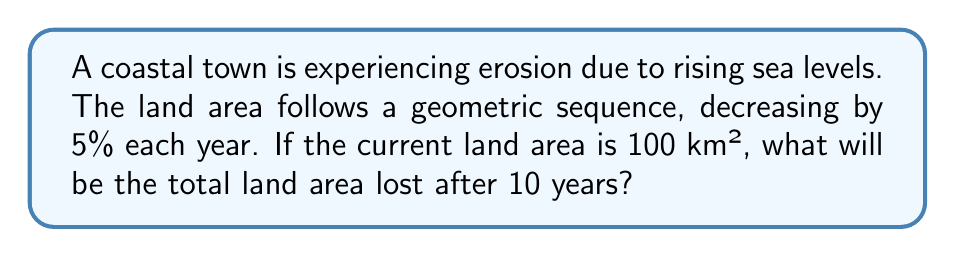Help me with this question. Let's approach this step-by-step:

1) The land area follows a geometric sequence with a common ratio of 0.95 (since it decreases by 5% each year, it retains 95% of its area).

2) The initial area $a_0 = 100$ km².

3) After 10 years, the area will be:
   $a_{10} = 100 \cdot (0.95)^{10}$ km²

4) To calculate this:
   $a_{10} = 100 \cdot (0.95)^{10} = 100 \cdot 0.5987 = 59.87$ km²

5) The total land area lost is the difference between the initial and final areas:
   $\text{Area lost} = a_0 - a_{10} = 100 - 59.87 = 40.13$ km²

6) To verify, we can use the sum of a geometric series formula:
   $$S_n = a_1\frac{1-r^n}{1-r}$$
   where $a_1 = 100 \cdot 0.05 = 5$ (the area lost in the first year) and $r = 0.95$

7) Plugging in the values:
   $$S_{10} = 5\frac{1-0.95^{10}}{1-0.95} = 5\frac{0.4013}{0.05} = 40.13$$ km²

This confirms our earlier calculation.
Answer: 40.13 km² 